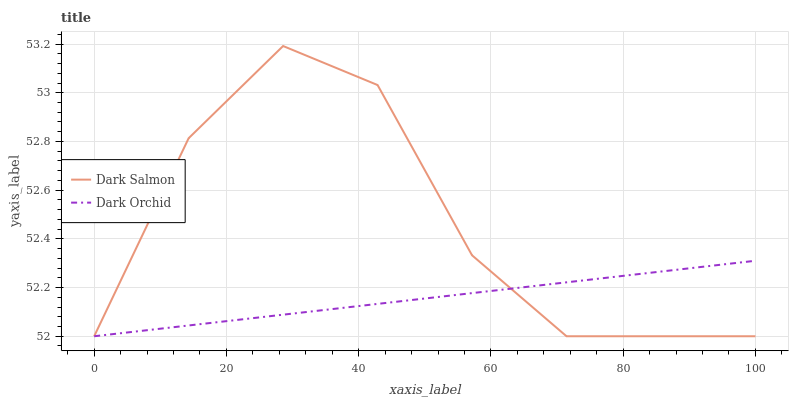Does Dark Orchid have the minimum area under the curve?
Answer yes or no. Yes. Does Dark Salmon have the maximum area under the curve?
Answer yes or no. Yes. Does Dark Orchid have the maximum area under the curve?
Answer yes or no. No. Is Dark Orchid the smoothest?
Answer yes or no. Yes. Is Dark Salmon the roughest?
Answer yes or no. Yes. Is Dark Orchid the roughest?
Answer yes or no. No. Does Dark Salmon have the lowest value?
Answer yes or no. Yes. Does Dark Salmon have the highest value?
Answer yes or no. Yes. Does Dark Orchid have the highest value?
Answer yes or no. No. Does Dark Salmon intersect Dark Orchid?
Answer yes or no. Yes. Is Dark Salmon less than Dark Orchid?
Answer yes or no. No. Is Dark Salmon greater than Dark Orchid?
Answer yes or no. No. 